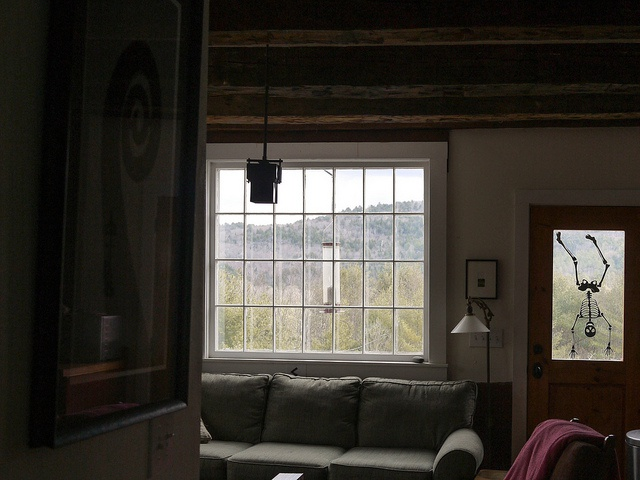Describe the objects in this image and their specific colors. I can see couch in black, gray, and darkgray tones and chair in black, maroon, and brown tones in this image. 